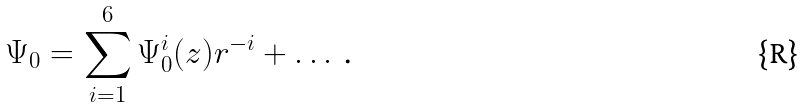Convert formula to latex. <formula><loc_0><loc_0><loc_500><loc_500>\Psi _ { 0 } = \sum _ { i = 1 } ^ { 6 } \Psi _ { 0 } ^ { i } ( z ) r ^ { - i } + \dots \text { .}</formula> 